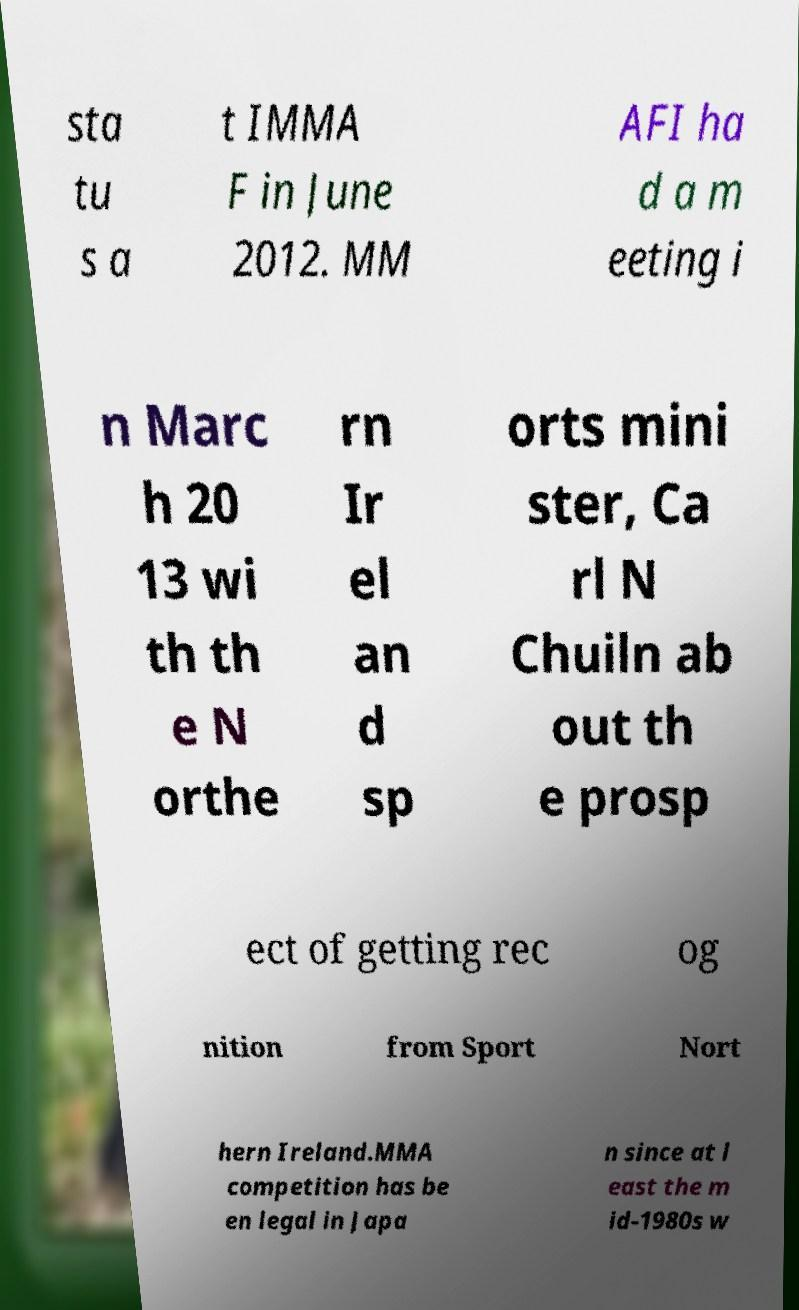I need the written content from this picture converted into text. Can you do that? sta tu s a t IMMA F in June 2012. MM AFI ha d a m eeting i n Marc h 20 13 wi th th e N orthe rn Ir el an d sp orts mini ster, Ca rl N Chuiln ab out th e prosp ect of getting rec og nition from Sport Nort hern Ireland.MMA competition has be en legal in Japa n since at l east the m id-1980s w 